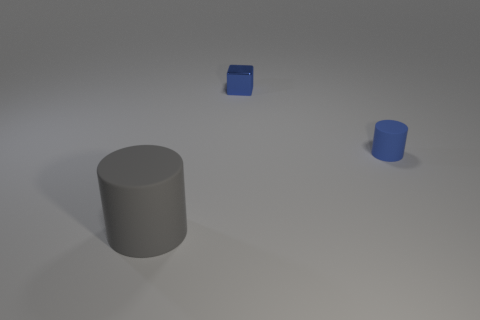Add 2 red metallic objects. How many objects exist? 5 Subtract all gray cylinders. How many cylinders are left? 1 Subtract 2 cylinders. How many cylinders are left? 0 Subtract all cylinders. How many objects are left? 1 Add 3 rubber cylinders. How many rubber cylinders are left? 5 Add 1 tiny blue matte things. How many tiny blue matte things exist? 2 Subtract 1 blue cylinders. How many objects are left? 2 Subtract all purple cylinders. Subtract all yellow blocks. How many cylinders are left? 2 Subtract all cyan balls. How many gray cylinders are left? 1 Subtract all small yellow balls. Subtract all tiny blue rubber objects. How many objects are left? 2 